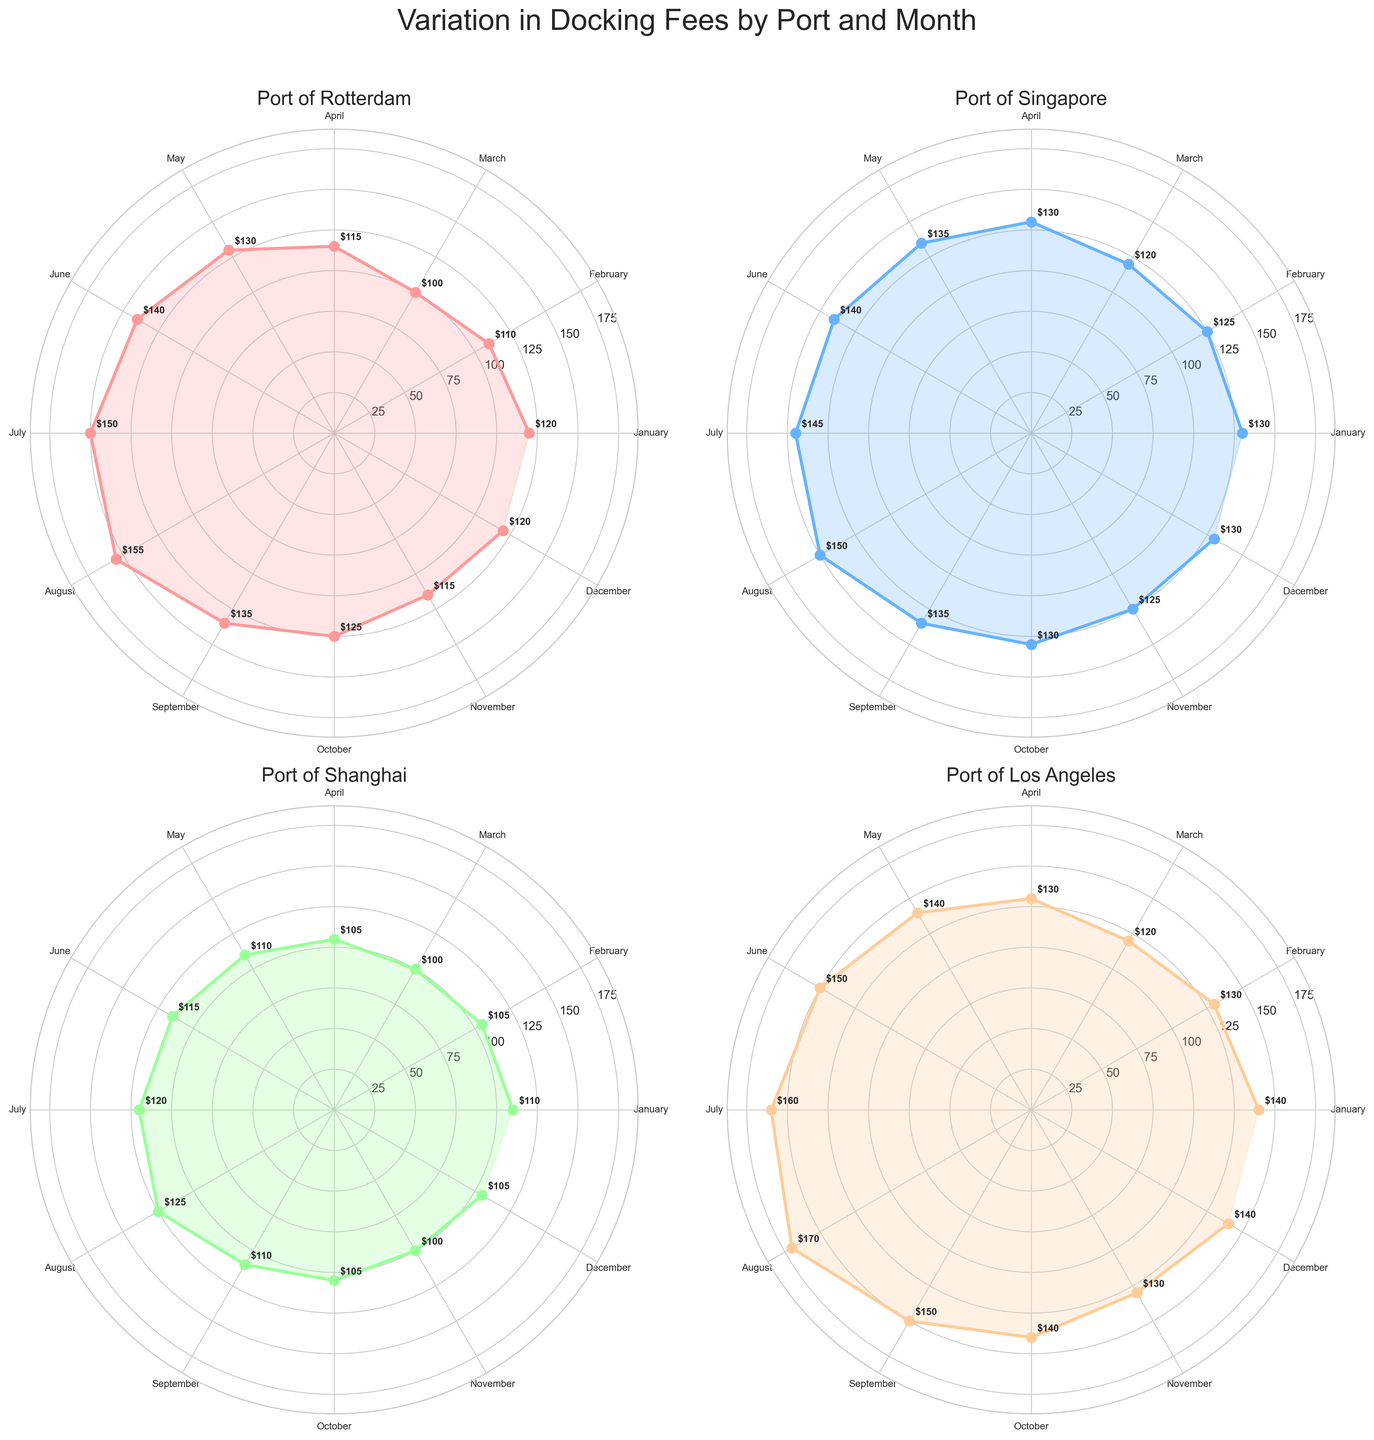What's the title of the figure? The title is located at the top of the figure and reads "Variation in Docking Fees by Port and Month."
Answer: Variation in Docking Fees by Port and Month How many ports are displayed in the figure? Each subplot represents a different port, and there are a total of 4 subplots.
Answer: 4 Which port has the highest docking fee in August? In the polar plot for August, the mark reaches the highest value in the "Port of Los Angeles" subplot.
Answer: Port of Los Angeles What is the range of docking fees for the Port of Rotterdam? The lowest fee for the Port of Rotterdam is 100 in March, and the highest is 155 in August. The range is 155 - 100 = 55.
Answer: 55 Which month has the lowest docking fee for the Port of Shanghai? By looking at the subplot for the Port of Shanghai, it is clear that the lowest fee is in March and November, both with a fee of 100.
Answer: March and November Among the ports shown, which one has the most consistent docking fee throughout the year? Consistent fees will show less variation in the size of the plotted area. The Port of Shanghai has the least variation, ranging from 100 to 125.
Answer: Port of Shanghai What is the average docking fee for the Port of Singapore across all months? Add up all the docking fees for each month and divide by 12. The values are 130 + 125 + 120 + 130 + 135 + 140 + 145 + 150 + 135 + 130 + 125 + 130. The sum is 1595. The average is 1595 / 12 ≈ 132.92.
Answer: ≈ 132.92 Which port shows the highest variation in docking fees throughout the year? The plot for the Port of Los Angeles shows the highest variation with fees ranging from 120 in March to 170 in August, a spread of 50 units.
Answer: Port of Los Angeles Is there any month where all ports have docking fees within the same range? Analyze each month across all subplots. Only in June do all ports have fees close to each other: Rotterdam (140), Singapore (140), Shanghai (115), and Los Angeles (150).
Answer: June 